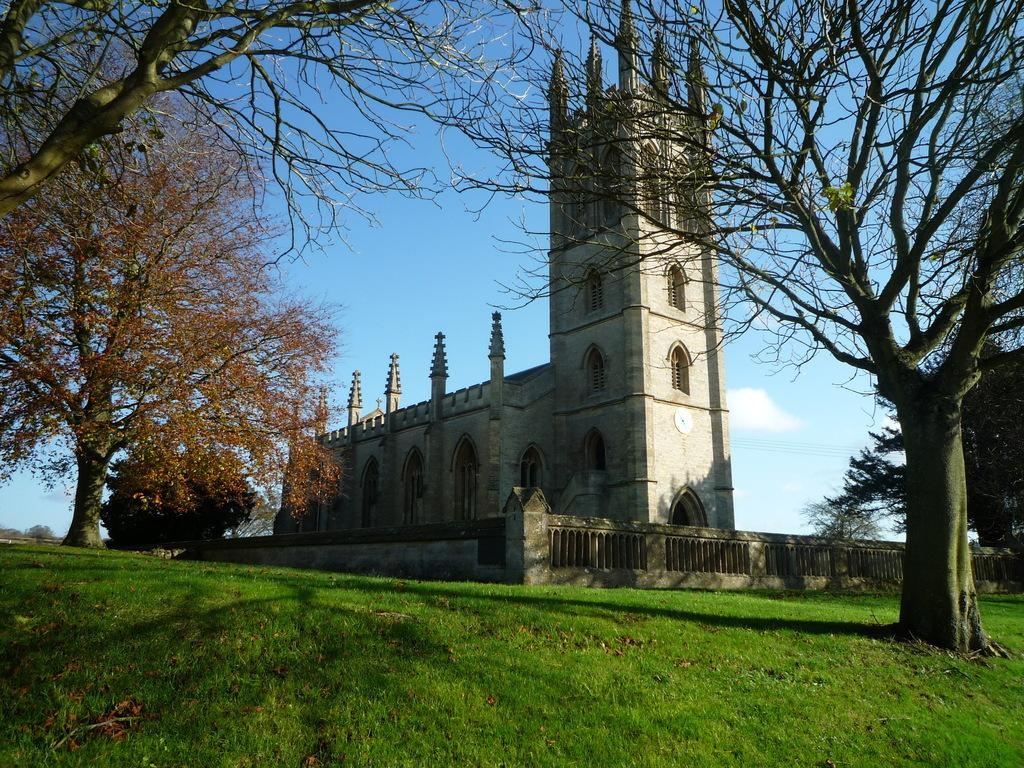What type of structure is present in the image? There is a building in the image. What color is the building? The building is gray. What type of vegetation can be seen in the image? There is grass in the image. What color is the grass? The grass is green. What type of trees are present in the image? There are dried trees in the image. What is the color of the sky in the image? The sky is blue and white. How many boats are sailing in the sky in the image? There are no boats present in the image, as it features a building, grass, dried trees, and a blue and white sky. 